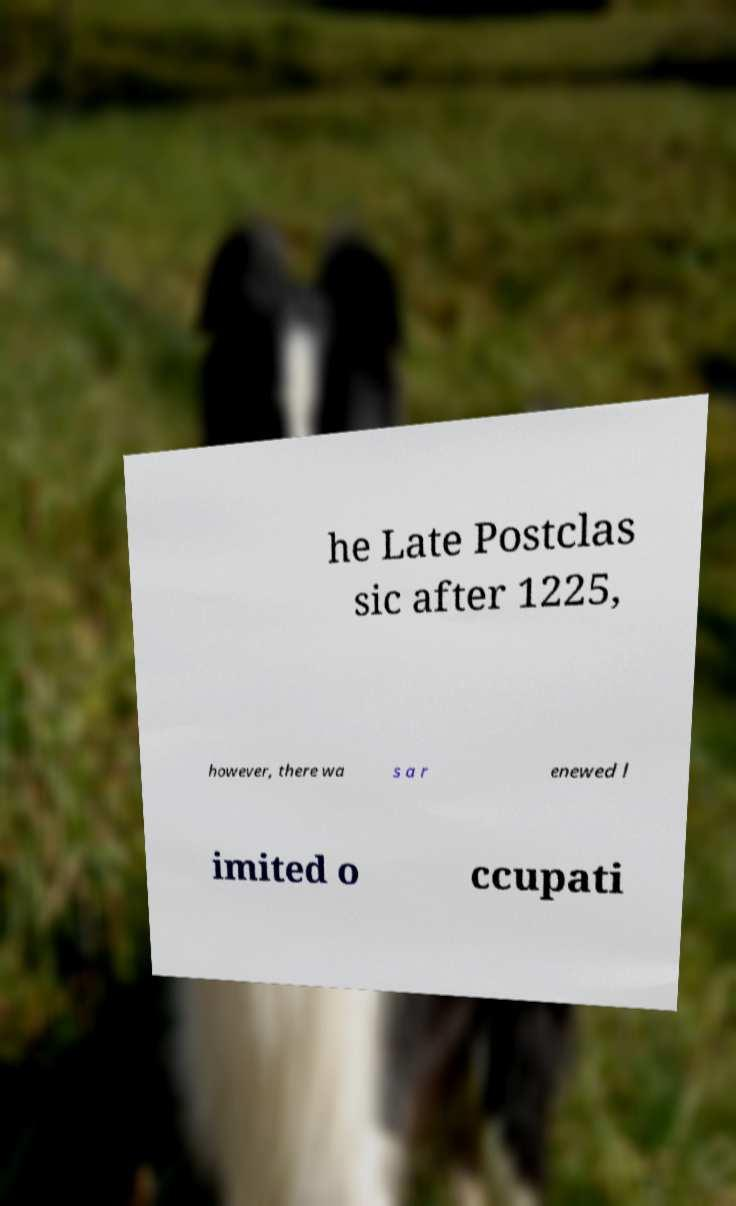For documentation purposes, I need the text within this image transcribed. Could you provide that? he Late Postclas sic after 1225, however, there wa s a r enewed l imited o ccupati 